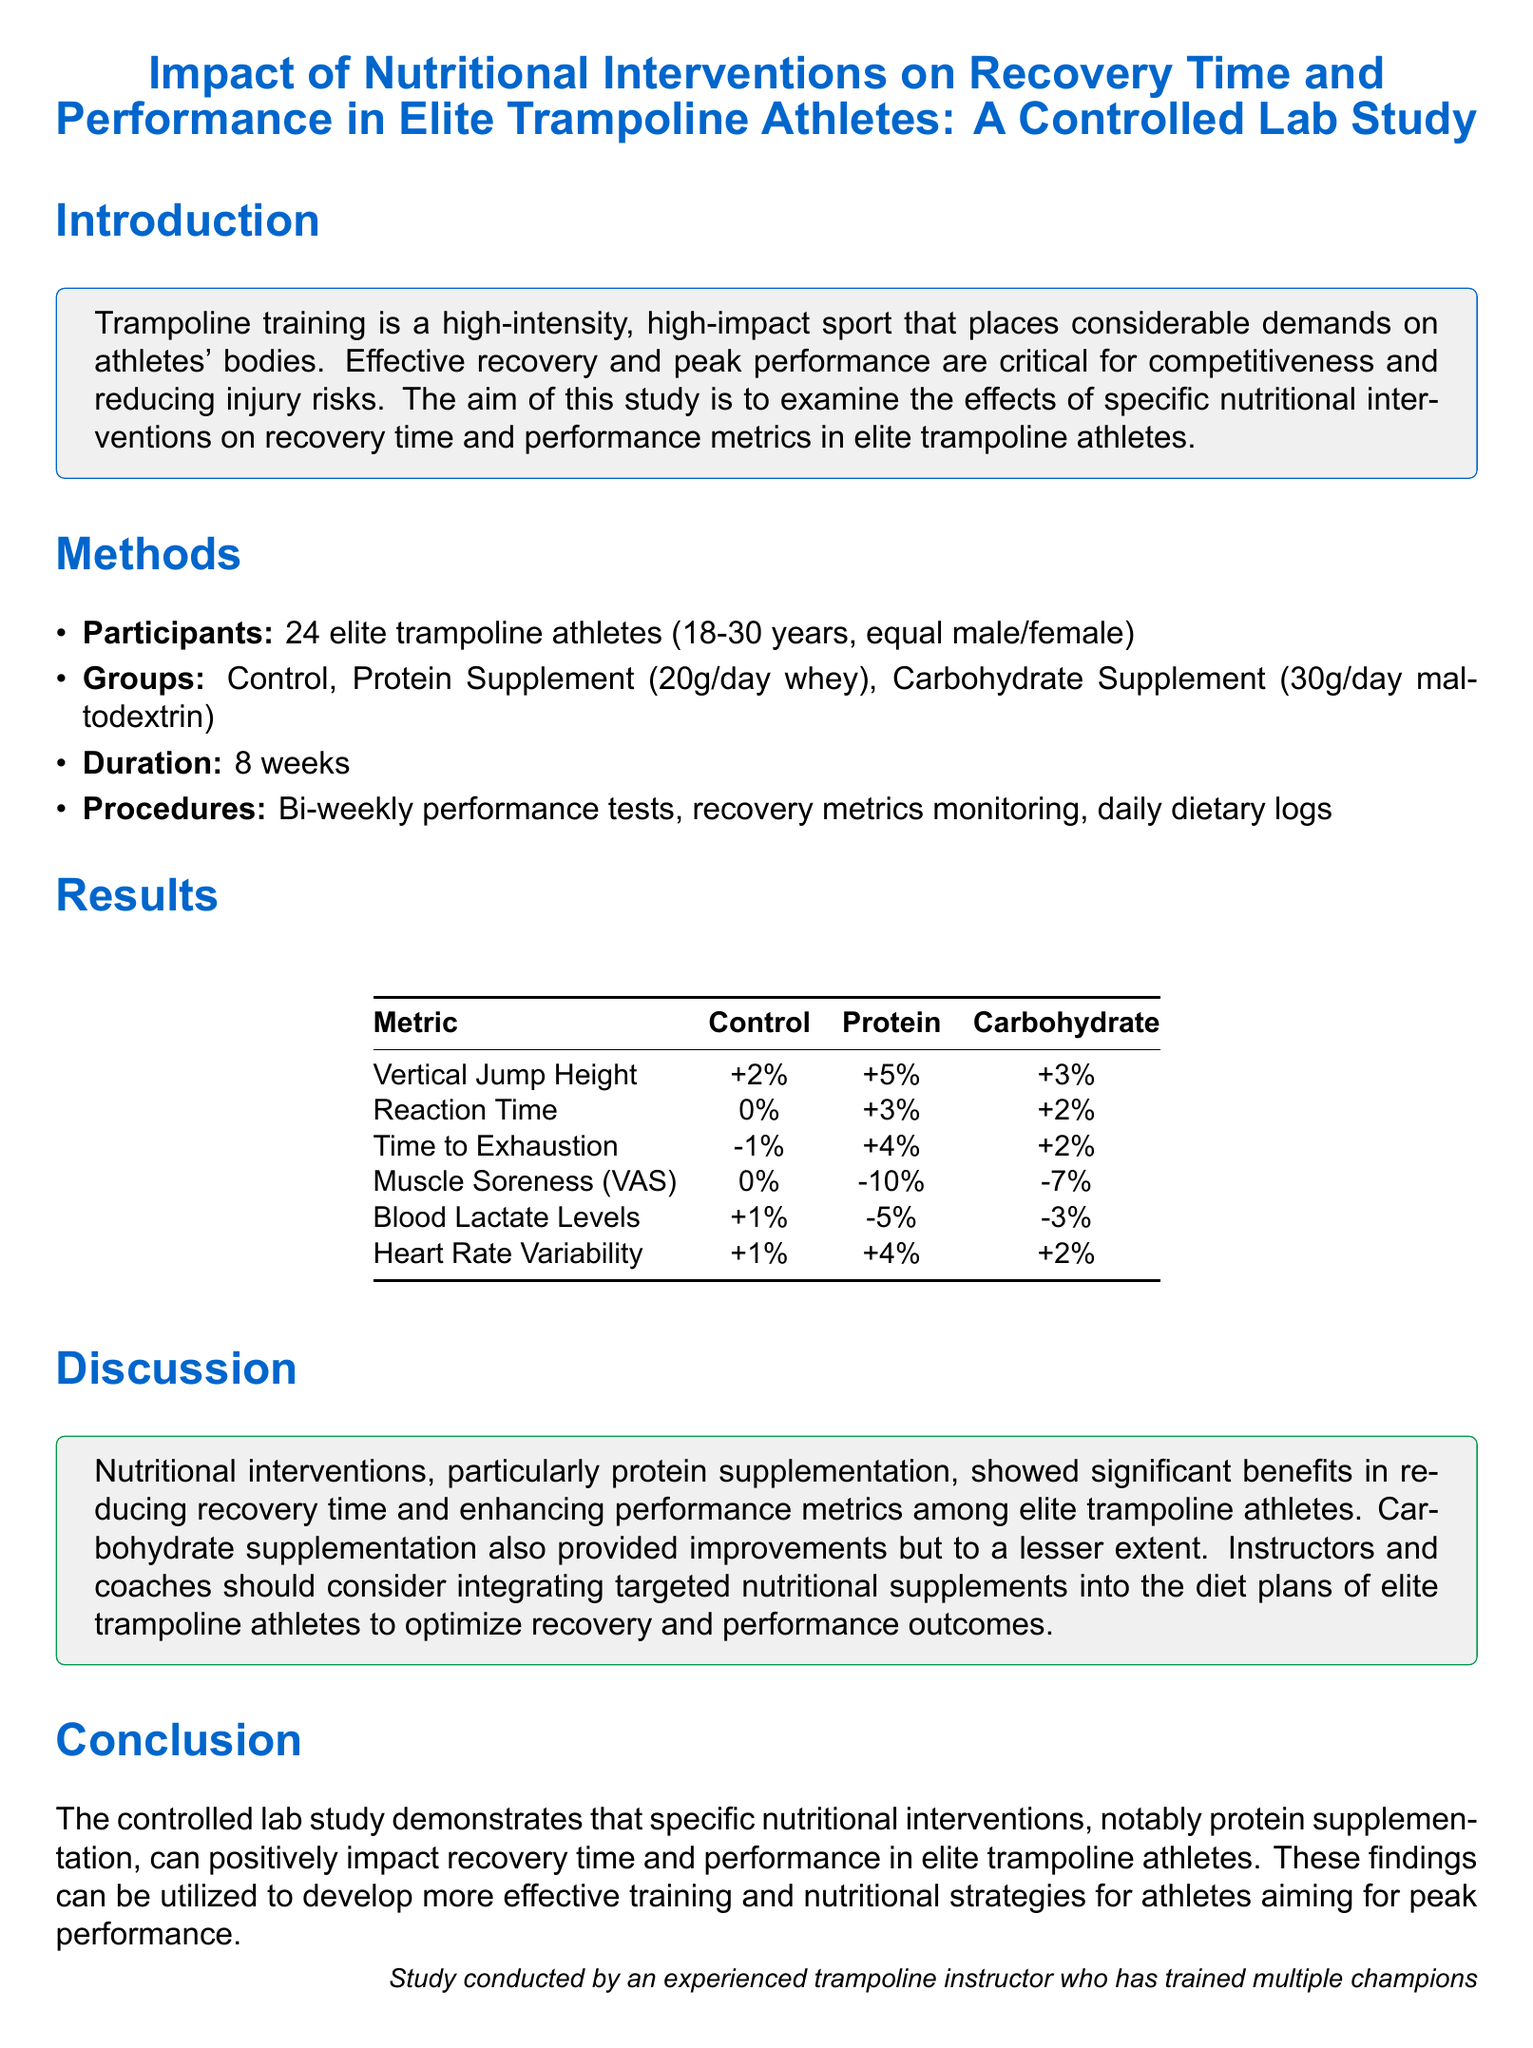What is the main aim of the study? The main aim is to examine the effects of specific nutritional interventions on recovery time and performance metrics in elite trampoline athletes.
Answer: Examine effects of nutritional interventions How many participants were involved in the study? The number of participants is stated in the methods section. There were 24 elite trampoline athletes.
Answer: 24 What type of supplement was given to the Protein group? The type of supplement is specified in the methods section as whey.
Answer: Whey What was the increase in vertical jump height for the Protein group? The result for vertical jump height for the Protein group is shown in the results table.
Answer: +5% Which nutritional intervention showed the most significant reduction in muscle soreness? The reduction in muscle soreness is noted in the results section and indicates the best results from protein supplementation.
Answer: Protein What metric showed a decrease for the Control group? The results table indicates various metrics; looking closely, the Control group showed a decrease in time to exhaustion.
Answer: Time to Exhaustion What percentage did blood lactate levels decrease in the Protein group? This information can be found in the results table under blood lactate levels.
Answer: -5% In which section does the authors recommend integrating nutritional supplements? The recommendation is in the discussion section, where benefits of nutrition are discussed for athletes.
Answer: Discussion What key conclusion can be drawn from the study about protein supplementation? The conclusion highlights the positive impact of protein supplementation on recovery time and performance metrics.
Answer: Positive impact on recovery and performance What method was used to monitor recovery metrics? The methods section specifies the daily dietary logs as one of the monitoring procedures.
Answer: Daily dietary logs 